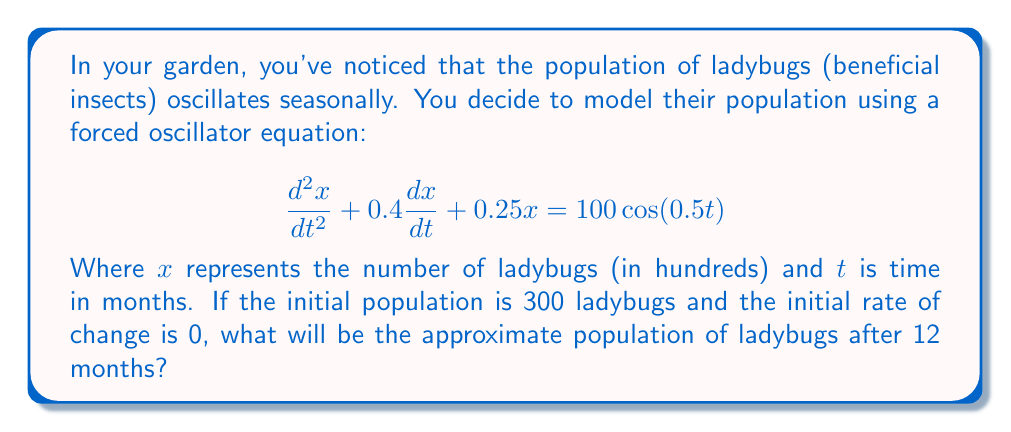Provide a solution to this math problem. To solve this problem, we need to find the general solution to the forced oscillator equation and then apply the initial conditions. Here's a step-by-step approach:

1. The general solution to this equation is the sum of the complementary solution (homogeneous solution) and the particular solution.

2. For the complementary solution, we solve the characteristic equation:
   $$r^2 + 0.4r + 0.25 = 0$$
   Using the quadratic formula, we get:
   $$r = -0.2 \pm 0.3i$$

3. The complementary solution is therefore:
   $$x_c(t) = e^{-0.2t}(A\cos(0.3t) + B\sin(0.3t))$$

4. For the particular solution, we assume a form:
   $$x_p(t) = C\cos(0.5t) + D\sin(0.5t)$$

5. Substituting this into the original equation and solving for C and D, we get:
   $$x_p(t) = 160\cos(0.5t) - 64\sin(0.5t)$$

6. The general solution is:
   $$x(t) = e^{-0.2t}(A\cos(0.3t) + B\sin(0.3t)) + 160\cos(0.5t) - 64\sin(0.5t)$$

7. Apply the initial conditions:
   $x(0) = 3$ and $x'(0) = 0$

8. Solving for A and B, we get:
   $A = -157$ and $B = -52.4$

9. The final solution is:
   $$x(t) = e^{-0.2t}(-157\cos(0.3t) - 52.4\sin(0.3t)) + 160\cos(0.5t) - 64\sin(0.5t)$$

10. To find the population after 12 months, we evaluate $x(12)$:
    $$x(12) \approx 4.23$$

11. Remember that $x$ represents hundreds of ladybugs, so we multiply by 100.
Answer: The approximate population of ladybugs after 12 months will be 423 ladybugs. 